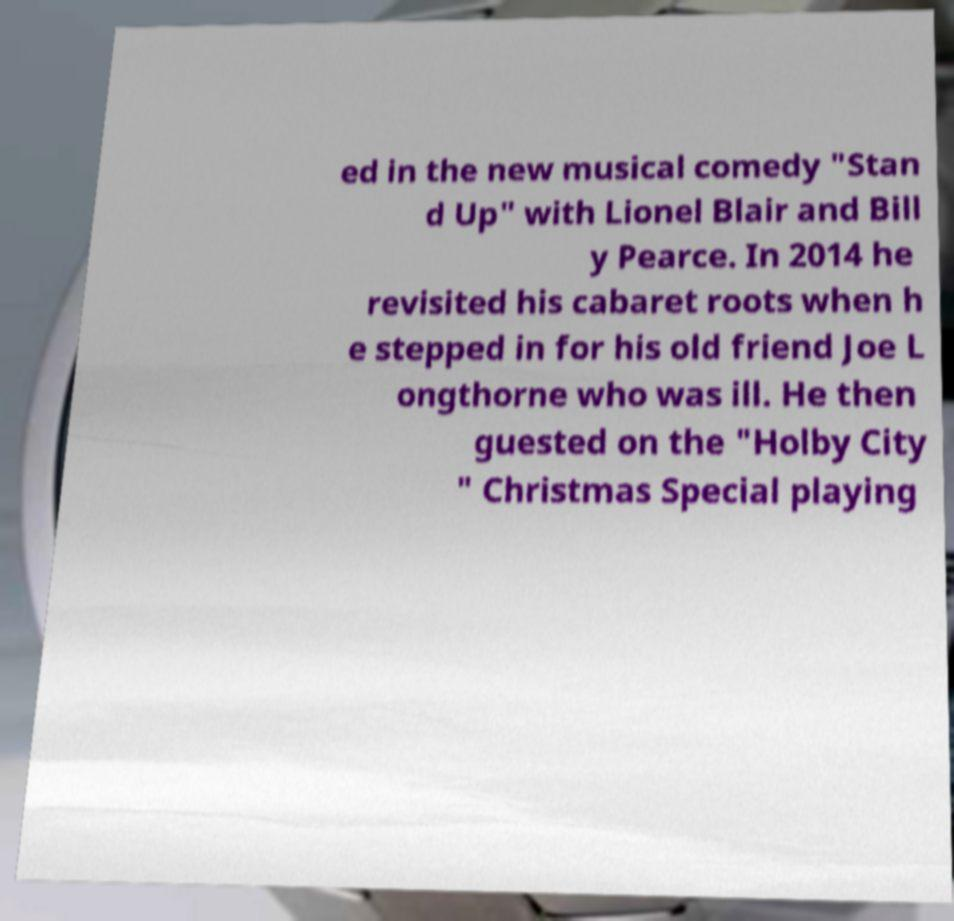What messages or text are displayed in this image? I need them in a readable, typed format. ed in the new musical comedy "Stan d Up" with Lionel Blair and Bill y Pearce. In 2014 he revisited his cabaret roots when h e stepped in for his old friend Joe L ongthorne who was ill. He then guested on the "Holby City " Christmas Special playing 